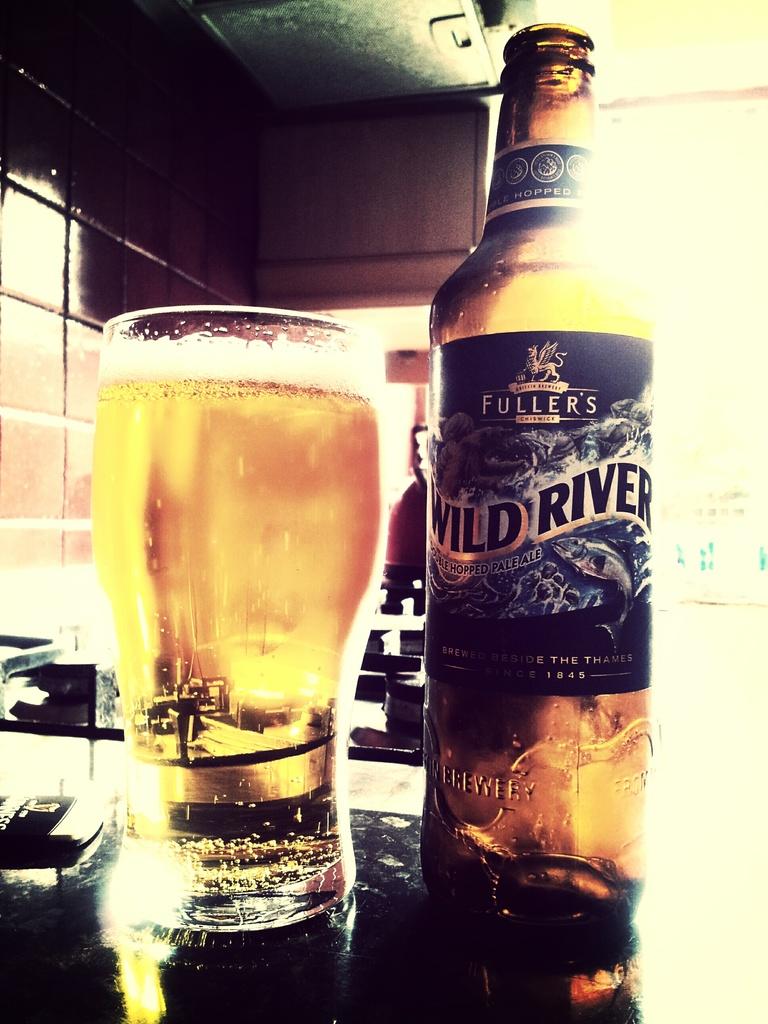What is the name of this beer?
Make the answer very short. Wild river. What year is this company established?
Keep it short and to the point. 1845. 